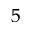Convert formula to latex. <formula><loc_0><loc_0><loc_500><loc_500>^ { 5 }</formula> 